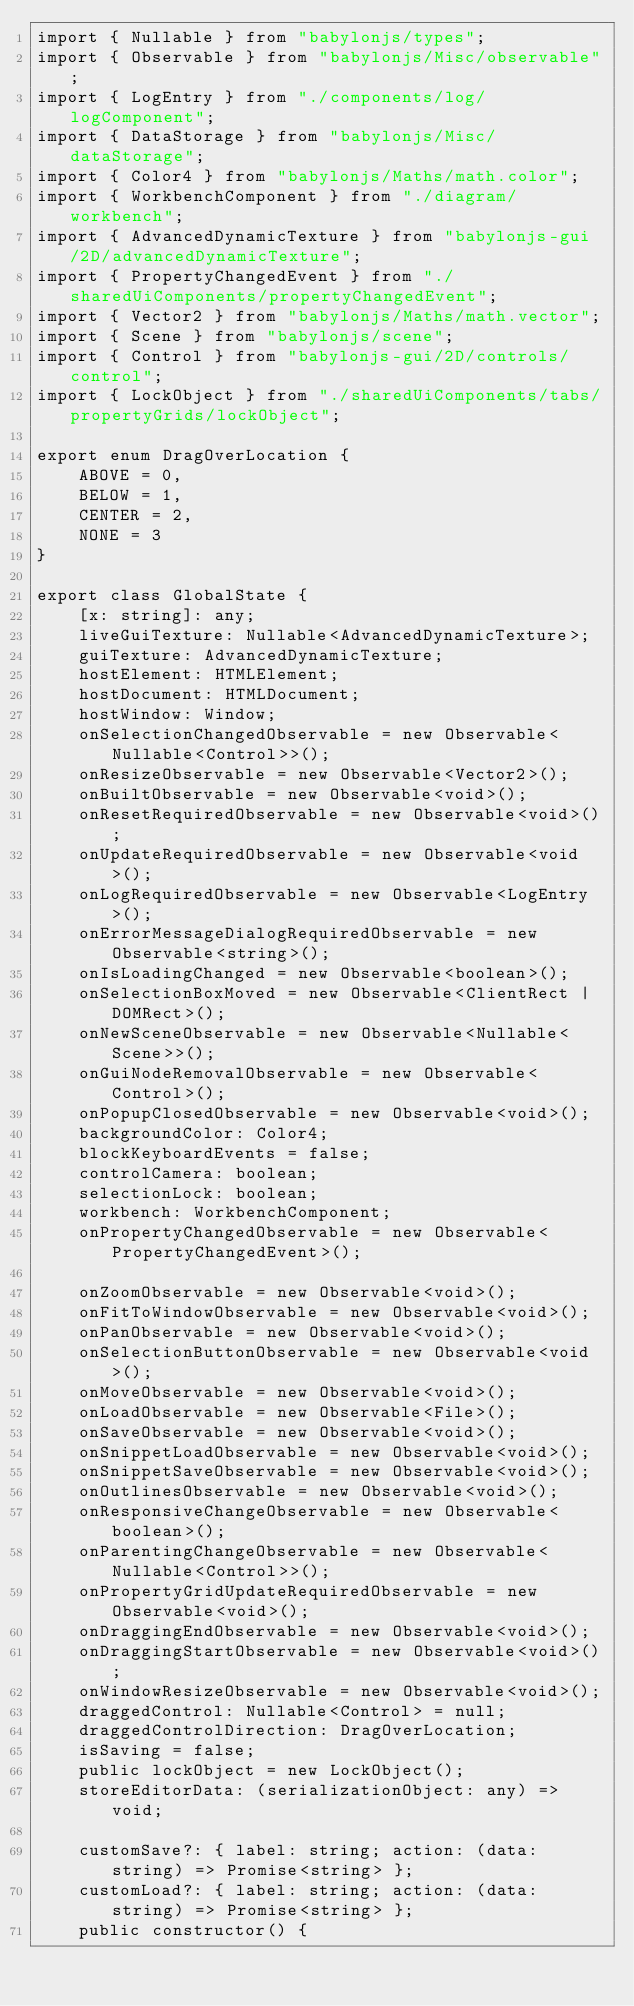Convert code to text. <code><loc_0><loc_0><loc_500><loc_500><_TypeScript_>import { Nullable } from "babylonjs/types";
import { Observable } from "babylonjs/Misc/observable";
import { LogEntry } from "./components/log/logComponent";
import { DataStorage } from "babylonjs/Misc/dataStorage";
import { Color4 } from "babylonjs/Maths/math.color";
import { WorkbenchComponent } from "./diagram/workbench";
import { AdvancedDynamicTexture } from "babylonjs-gui/2D/advancedDynamicTexture";
import { PropertyChangedEvent } from "./sharedUiComponents/propertyChangedEvent";
import { Vector2 } from "babylonjs/Maths/math.vector";
import { Scene } from "babylonjs/scene";
import { Control } from "babylonjs-gui/2D/controls/control";
import { LockObject } from "./sharedUiComponents/tabs/propertyGrids/lockObject";

export enum DragOverLocation {
    ABOVE = 0,
    BELOW = 1,
    CENTER = 2,
    NONE = 3
}

export class GlobalState {
    [x: string]: any;
    liveGuiTexture: Nullable<AdvancedDynamicTexture>;
    guiTexture: AdvancedDynamicTexture;
    hostElement: HTMLElement;
    hostDocument: HTMLDocument;
    hostWindow: Window;
    onSelectionChangedObservable = new Observable<Nullable<Control>>();
    onResizeObservable = new Observable<Vector2>();
    onBuiltObservable = new Observable<void>();
    onResetRequiredObservable = new Observable<void>();
    onUpdateRequiredObservable = new Observable<void>();
    onLogRequiredObservable = new Observable<LogEntry>();
    onErrorMessageDialogRequiredObservable = new Observable<string>();
    onIsLoadingChanged = new Observable<boolean>();
    onSelectionBoxMoved = new Observable<ClientRect | DOMRect>();
    onNewSceneObservable = new Observable<Nullable<Scene>>();
    onGuiNodeRemovalObservable = new Observable<Control>();
    onPopupClosedObservable = new Observable<void>();
    backgroundColor: Color4;
    blockKeyboardEvents = false;
    controlCamera: boolean;
    selectionLock: boolean;
    workbench: WorkbenchComponent;
    onPropertyChangedObservable = new Observable<PropertyChangedEvent>();

    onZoomObservable = new Observable<void>();
    onFitToWindowObservable = new Observable<void>();
    onPanObservable = new Observable<void>();
    onSelectionButtonObservable = new Observable<void>();
    onMoveObservable = new Observable<void>();
    onLoadObservable = new Observable<File>();
    onSaveObservable = new Observable<void>();
    onSnippetLoadObservable = new Observable<void>();
    onSnippetSaveObservable = new Observable<void>();
    onOutlinesObservable = new Observable<void>();
    onResponsiveChangeObservable = new Observable<boolean>();
    onParentingChangeObservable = new Observable<Nullable<Control>>();
    onPropertyGridUpdateRequiredObservable = new Observable<void>();
    onDraggingEndObservable = new Observable<void>();
    onDraggingStartObservable = new Observable<void>();
    onWindowResizeObservable = new Observable<void>();
    draggedControl: Nullable<Control> = null;
    draggedControlDirection: DragOverLocation;
    isSaving = false;
    public lockObject = new LockObject();
    storeEditorData: (serializationObject: any) => void;

    customSave?: { label: string; action: (data: string) => Promise<string> };
    customLoad?: { label: string; action: (data: string) => Promise<string> };
    public constructor() {</code> 